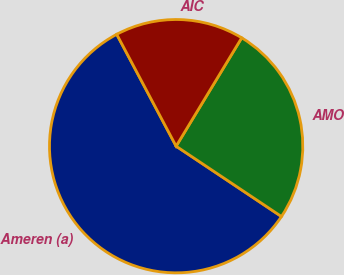<chart> <loc_0><loc_0><loc_500><loc_500><pie_chart><fcel>Ameren (a)<fcel>AMO<fcel>AIC<nl><fcel>57.86%<fcel>25.71%<fcel>16.43%<nl></chart> 